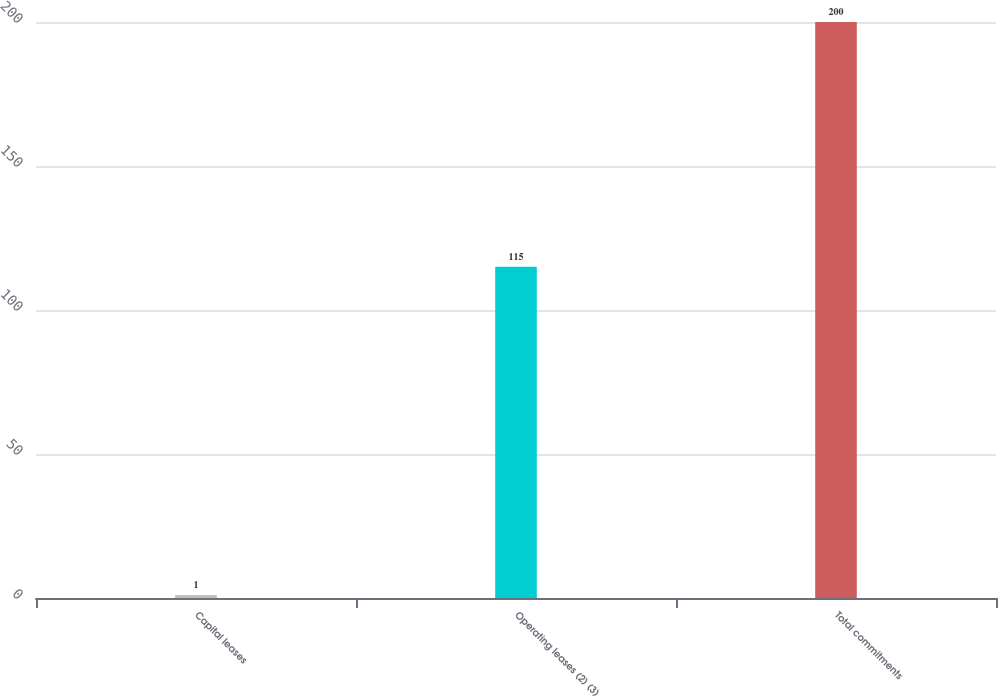<chart> <loc_0><loc_0><loc_500><loc_500><bar_chart><fcel>Capital leases<fcel>Operating leases (2) (3)<fcel>Total commitments<nl><fcel>1<fcel>115<fcel>200<nl></chart> 